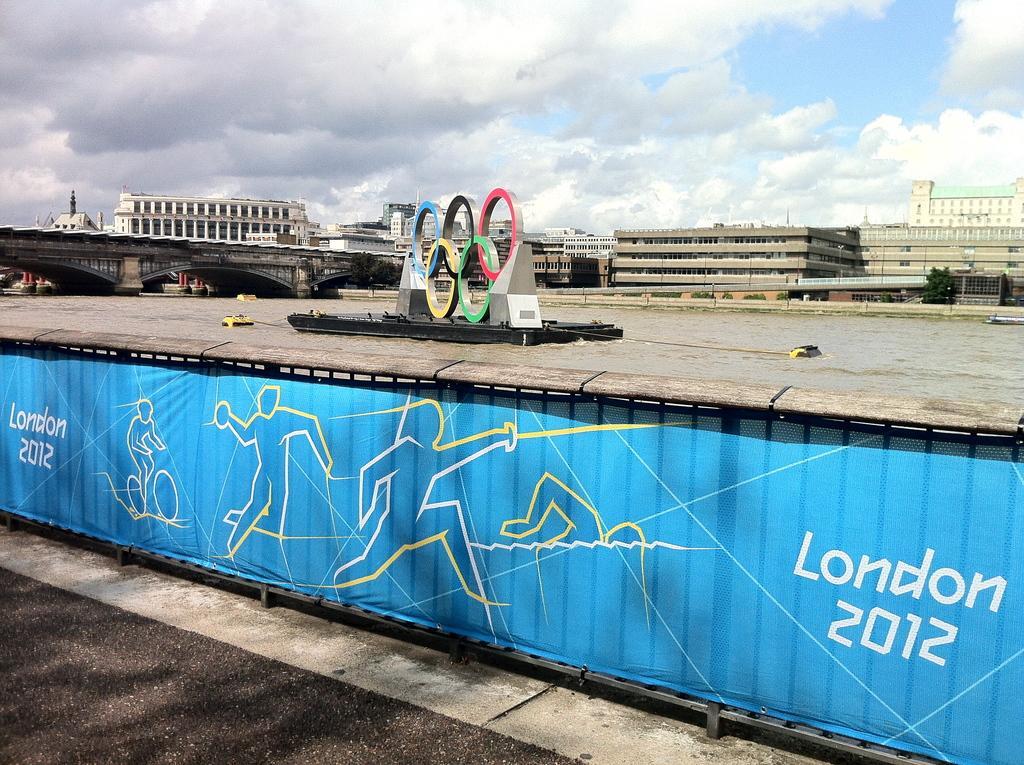Could you give a brief overview of what you see in this image? In this picture I can see fencing with banner, behind we can see some boats on the water surface, back ground we can see some buildings, trees, bridges. 